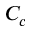Convert formula to latex. <formula><loc_0><loc_0><loc_500><loc_500>C _ { c }</formula> 